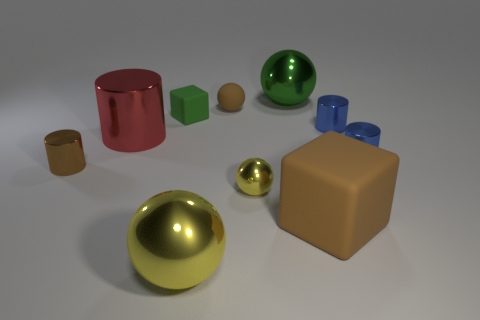Subtract all spheres. How many objects are left? 6 Subtract 0 yellow cylinders. How many objects are left? 10 Subtract all small brown objects. Subtract all large green objects. How many objects are left? 7 Add 1 red cylinders. How many red cylinders are left? 2 Add 8 small gray rubber things. How many small gray rubber things exist? 8 